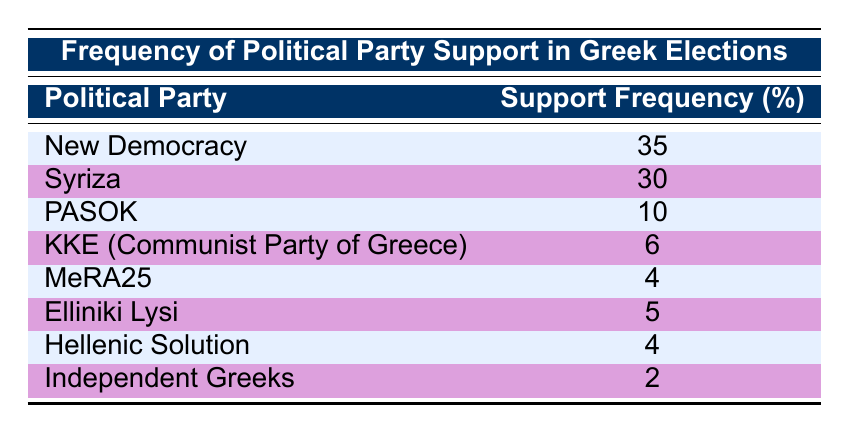What is the highest support frequency for a political party in Greece? The highest support frequency listed in the table is for New Democracy, with a support frequency of 35.
Answer: 35 What is the total support frequency of Syriza and PASOK combined? To find the total support frequency of Syriza and PASOK, we add their individual support frequencies: 30 (Syriza) + 10 (PASOK) = 40.
Answer: 40 Is the support frequency for KKE greater than that for MeRA25? The support frequency for KKE is 6 and for MeRA25 it is 4. Since 6 is greater than 4, the statement is true.
Answer: Yes How many political parties have a support frequency of less than 5? The political parties with a support frequency of less than 5 are MeRA25 (4), Hellenic Solution (4), and Independent Greeks (2), totaling 3 parties.
Answer: 3 What percentage of total support is accounted for by New Democracy and Syriza together? New Democracy has 35 and Syriza has 30. Their total support is 35 + 30 = 65. The total support frequency from the table sums to 92 (35 + 30 + 10 + 6 + 4 + 5 + 4 + 2 = 92). The percentage is (65/92) * 100 ≈ 70.65%.
Answer: Approximately 70.65% What is the difference in support frequency between the party with the highest support and the party with the lowest support? The party with the highest support is New Democracy (35), and the party with the lowest support is Independent Greeks (2). The difference is 35 - 2 = 33.
Answer: 33 Is the combined support frequency of Elliniki Lysi and Hellenic Solution greater than that of KKE? The support frequency for Elliniki Lysi is 5, and for Hellenic Solution is 4, giving a combined total of 5 + 4 = 9. KKE has a support frequency of 6. Since 9 is greater than 6, the statement is true.
Answer: Yes How many parties have a support frequency of 6 or more? The parties with a support frequency of 6 or more are New Democracy (35), Syriza (30), PASOK (10), and KKE (6), totaling 4 parties.
Answer: 4 